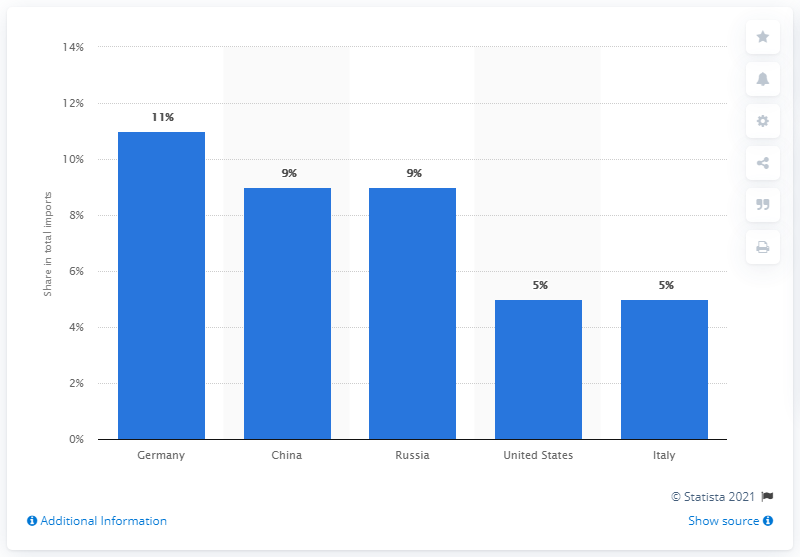Mention a couple of crucial points in this snapshot. In 2019, Germany had a significant percentage of its imports. According to data from 2019, Germany was the leading import partner of Turkey. 